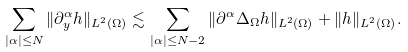Convert formula to latex. <formula><loc_0><loc_0><loc_500><loc_500>\sum _ { | \alpha | \leq N } \| \partial ^ { \alpha } _ { y } h \| _ { L ^ { 2 } ( \Omega ) } \lesssim \sum _ { | \alpha | \leq N - 2 } \| \partial ^ { \alpha } \Delta _ { \Omega } h \| _ { L ^ { 2 } ( \Omega ) } + \| h \| _ { L ^ { 2 } ( \Omega ) } .</formula> 